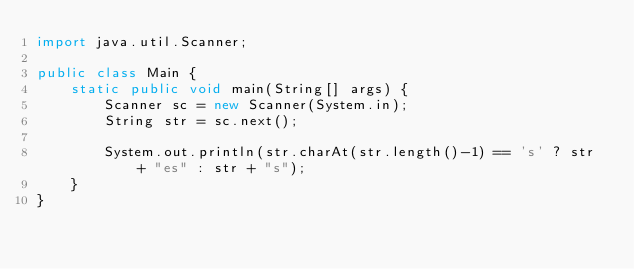<code> <loc_0><loc_0><loc_500><loc_500><_Java_>import java.util.Scanner;

public class Main {
    static public void main(String[] args) {
        Scanner sc = new Scanner(System.in);
        String str = sc.next();

        System.out.println(str.charAt(str.length()-1) == 's' ? str + "es" : str + "s");
    }
}
</code> 